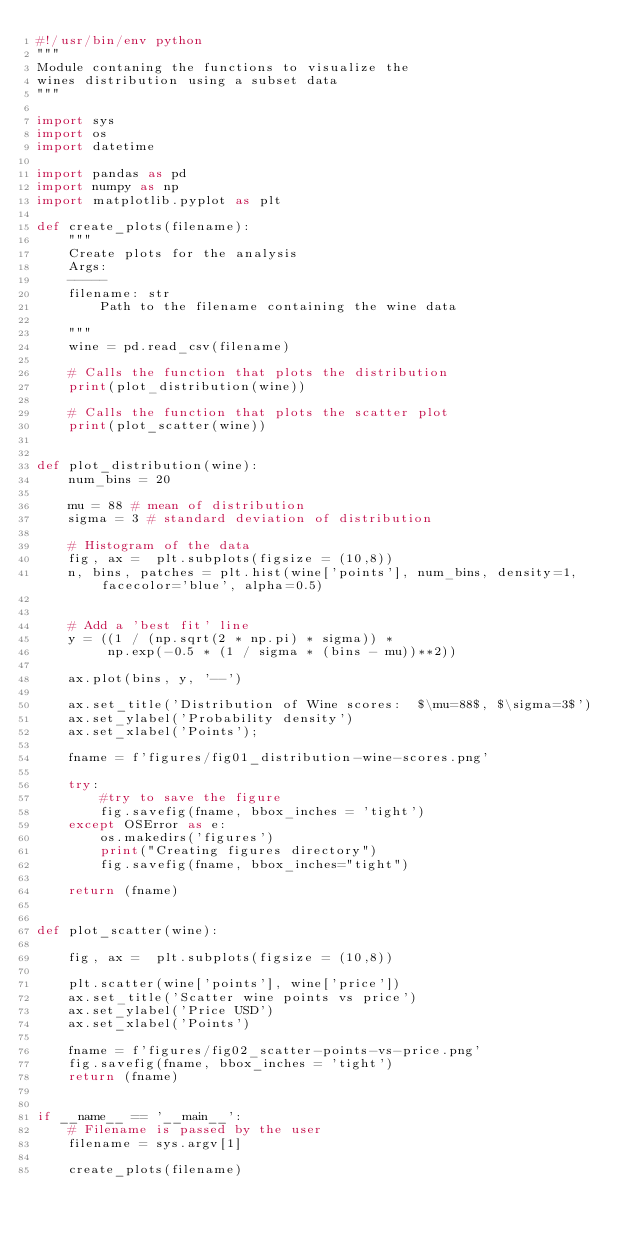Convert code to text. <code><loc_0><loc_0><loc_500><loc_500><_Python_>#!/usr/bin/env python
"""
Module contaning the functions to visualize the
wines distribution using a subset data
"""

import sys
import os
import datetime

import pandas as pd
import numpy as np
import matplotlib.pyplot as plt

def create_plots(filename):
    """
    Create plots for the analysis
    Args:
    -----
    filename: str
        Path to the filename containing the wine data

    """
    wine = pd.read_csv(filename)

    # Calls the function that plots the distribution
    print(plot_distribution(wine))

    # Calls the function that plots the scatter plot
    print(plot_scatter(wine))


def plot_distribution(wine):
    num_bins = 20

    mu = 88 # mean of distribution
    sigma = 3 # standard deviation of distribution

    # Histogram of the data
    fig, ax =  plt.subplots(figsize = (10,8))
    n, bins, patches = plt.hist(wine['points'], num_bins, density=1, facecolor='blue', alpha=0.5)


    # Add a 'best fit' line
    y = ((1 / (np.sqrt(2 * np.pi) * sigma)) *
         np.exp(-0.5 * (1 / sigma * (bins - mu))**2))

    ax.plot(bins, y, '--')

    ax.set_title('Distribution of Wine scores:  $\mu=88$, $\sigma=3$')
    ax.set_ylabel('Probability density')
    ax.set_xlabel('Points');

    fname = f'figures/fig01_distribution-wine-scores.png'

    try:
        #try to save the figure
        fig.savefig(fname, bbox_inches = 'tight')
    except OSError as e:
        os.makedirs('figures')
        print("Creating figures directory")
        fig.savefig(fname, bbox_inches="tight")

    return (fname)


def plot_scatter(wine):

    fig, ax =  plt.subplots(figsize = (10,8))

    plt.scatter(wine['points'], wine['price'])
    ax.set_title('Scatter wine points vs price')
    ax.set_ylabel('Price USD')
    ax.set_xlabel('Points')

    fname = f'figures/fig02_scatter-points-vs-price.png'
    fig.savefig(fname, bbox_inches = 'tight')
    return (fname)


if __name__ == '__main__':
    # Filename is passed by the user
    filename = sys.argv[1]

    create_plots(filename)
</code> 